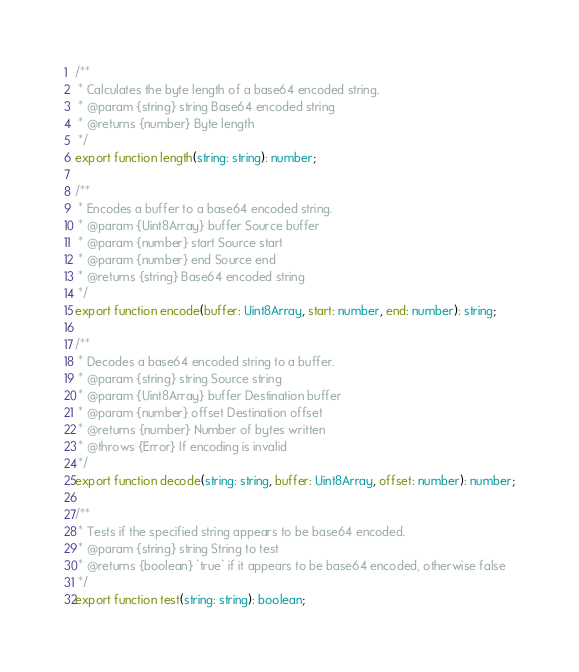<code> <loc_0><loc_0><loc_500><loc_500><_TypeScript_>/**
 * Calculates the byte length of a base64 encoded string.
 * @param {string} string Base64 encoded string
 * @returns {number} Byte length
 */
export function length(string: string): number;

/**
 * Encodes a buffer to a base64 encoded string.
 * @param {Uint8Array} buffer Source buffer
 * @param {number} start Source start
 * @param {number} end Source end
 * @returns {string} Base64 encoded string
 */
export function encode(buffer: Uint8Array, start: number, end: number): string;

/**
 * Decodes a base64 encoded string to a buffer.
 * @param {string} string Source string
 * @param {Uint8Array} buffer Destination buffer
 * @param {number} offset Destination offset
 * @returns {number} Number of bytes written
 * @throws {Error} If encoding is invalid
 */
export function decode(string: string, buffer: Uint8Array, offset: number): number;

/**
 * Tests if the specified string appears to be base64 encoded.
 * @param {string} string String to test
 * @returns {boolean} `true` if it appears to be base64 encoded, otherwise false
 */
export function test(string: string): boolean;
</code> 